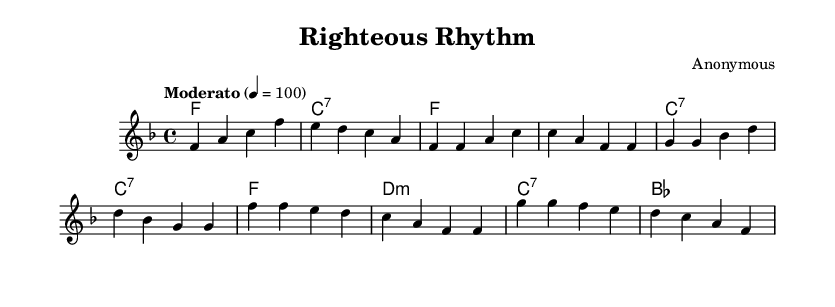What is the key signature of this music? The key signature indicated is F major, which has one flat (B-flat). This can be determined by looking at the key signature notation at the beginning of the sheet music.
Answer: F major What is the time signature of this music? The time signature specified in the score is 4/4, which means there are four beats in each measure, and the quarter note receives one beat. This is indicated at the beginning of the piece.
Answer: 4/4 What is the tempo marking of the piece? The tempo marking is "Moderato," indicating a moderate pace, and it is set at 4 beats per minute to 100. This can be found near the beginning where the tempo is specified.
Answer: Moderato How many measures are in the chorus section? The chorus section consists of four measures, which can be counted from the score where the chorus starts and spans until it ends.
Answer: Four What is the first chord in the harmony? The first chord in the harmony is F major, which is indicated at the beginning of the chord progression. This can be identified by looking at the chord symbols at the start of the score.
Answer: F What is the overall mood suggested by the tempo and style of this piece? The overall mood suggests a reflective and hopeful atmosphere based on the moderate tempo and the use of gospel-inspired harmony and melody. Considering the context of social justice themes, this mood aligns with the message.
Answer: Reflective What musical genre is represented in this piece? The musical genre represented is gospel-inspired jazz fusion, characterized by a blend of jazz elements with gospel themes and social justice motifs in its structure and style. This can be inferred from the title and overall musical context.
Answer: Gospel-inspired jazz fusion 